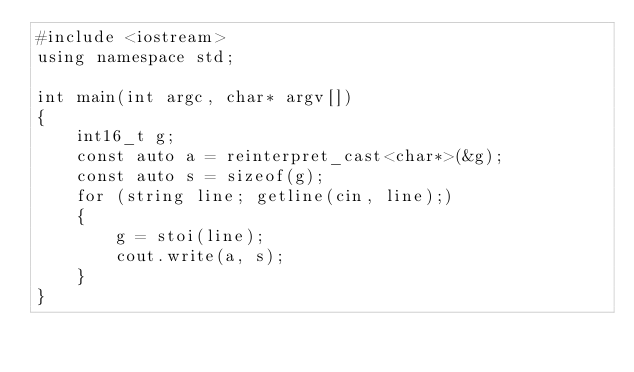Convert code to text. <code><loc_0><loc_0><loc_500><loc_500><_C++_>#include <iostream>
using namespace std;

int main(int argc, char* argv[])
{
	int16_t g;
	const auto a = reinterpret_cast<char*>(&g);
	const auto s = sizeof(g);
	for (string line; getline(cin, line);)
	{
		g = stoi(line);
		cout.write(a, s);
	}
}
</code> 